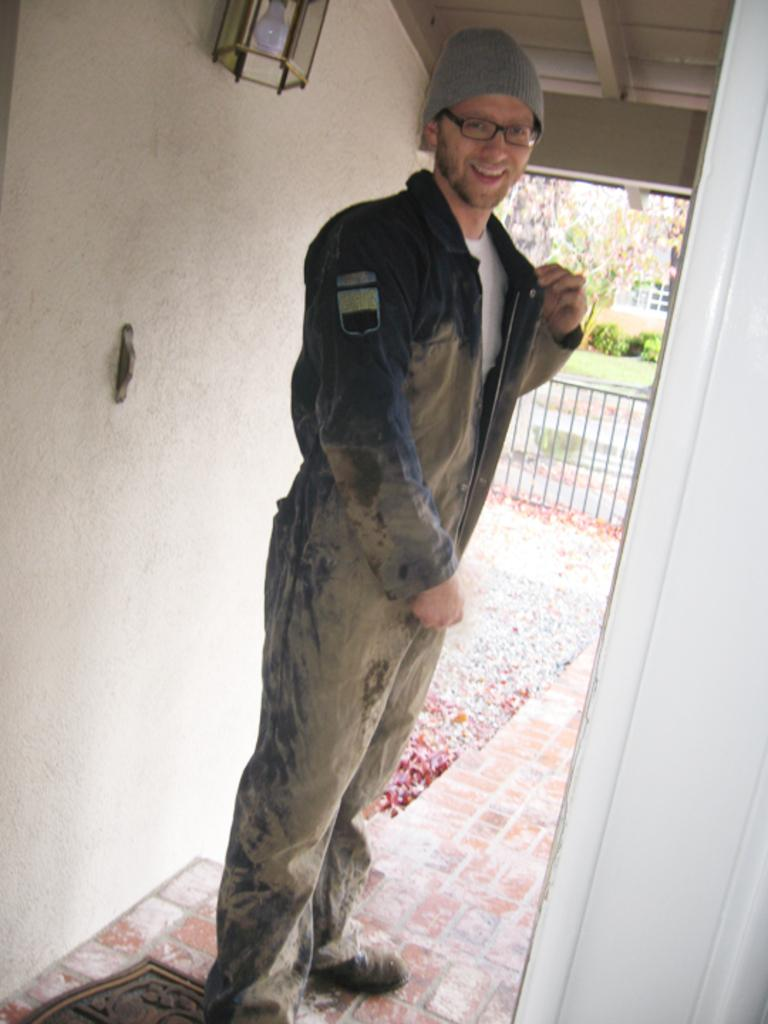What is the person in the image wearing on their head? The person is wearing a cap in the image. What type of eye protection is the person wearing? The person is wearing goggles in the image. What can be seen attached to the wall in the image? There is a light attached to the wall in the image. What type of barrier is present in the image? There is a fence in the image. What type of plant can be seen in the image? There is a tree and garden plants in the image. What type of ground cover is present in the image? There is grass in the image. What type of structure is visible in the image? There is a building in the image. What color is the donkey standing next to the tree in the image? There is no donkey present in the image. What type of container is used for bathing in the image? There is no tub or any container for bathing present in the image. 